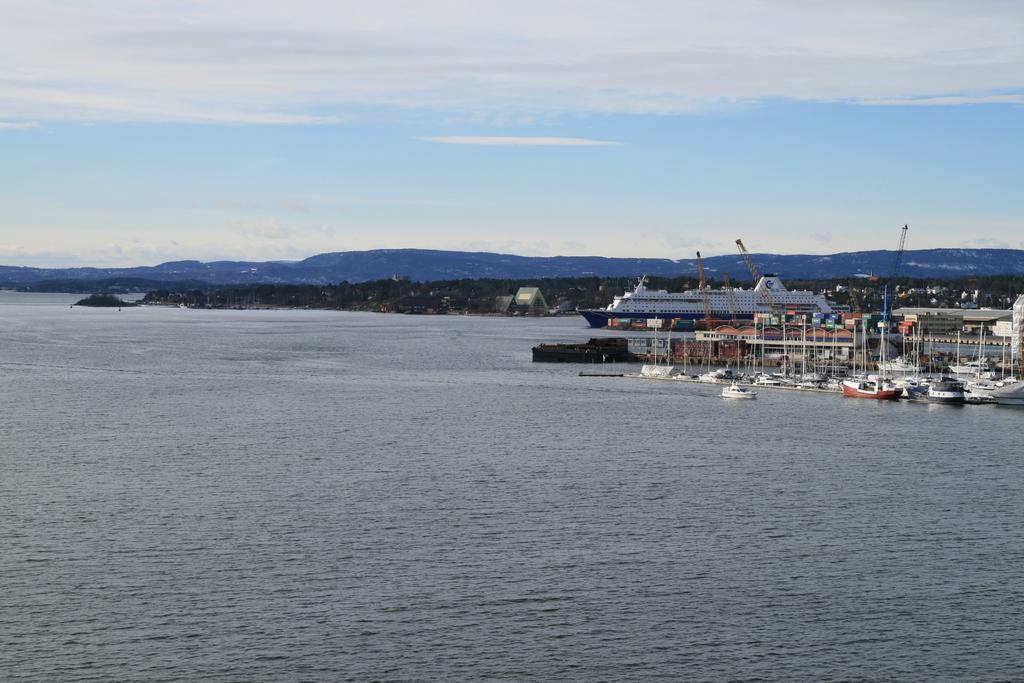Describe this image in one or two sentences. In this picture we can see few boats and a ship on the water, in the background we can find few cranes, trees, hills and clouds, on the right side of the image we can find few buildings. 